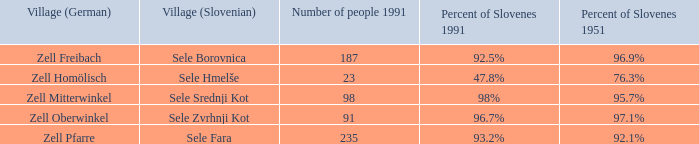Give me the minimum number of people in 1991 with 92.5% of Slovenes in 1991. 187.0. 